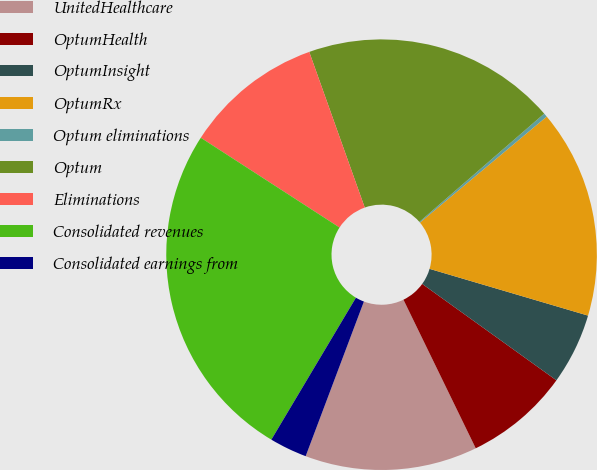<chart> <loc_0><loc_0><loc_500><loc_500><pie_chart><fcel>UnitedHealthcare<fcel>OptumHealth<fcel>OptumInsight<fcel>OptumRx<fcel>Optum eliminations<fcel>Optum<fcel>Eliminations<fcel>Consolidated revenues<fcel>Consolidated earnings from<nl><fcel>12.94%<fcel>7.88%<fcel>5.35%<fcel>15.65%<fcel>0.29%<fcel>19.08%<fcel>10.41%<fcel>25.59%<fcel>2.82%<nl></chart> 